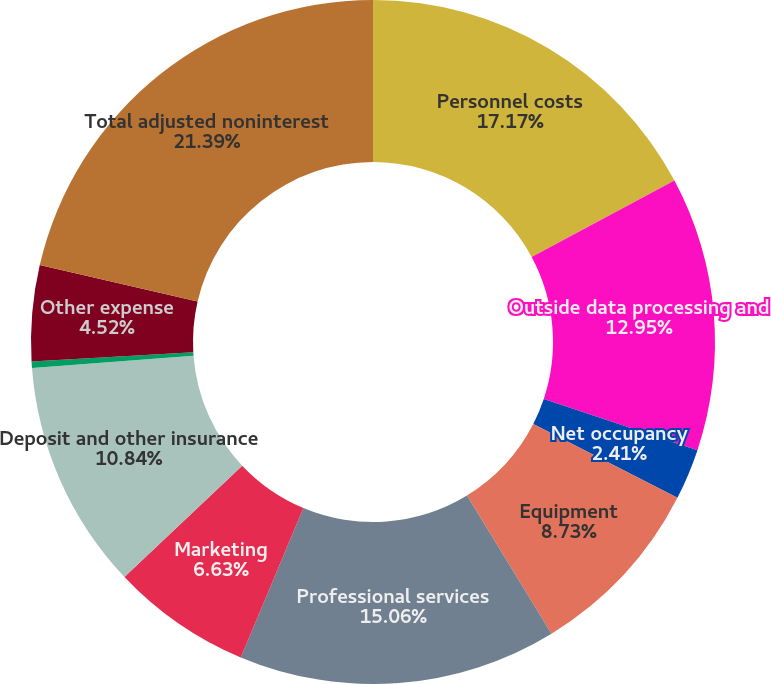Convert chart. <chart><loc_0><loc_0><loc_500><loc_500><pie_chart><fcel>Personnel costs<fcel>Outside data processing and<fcel>Net occupancy<fcel>Equipment<fcel>Professional services<fcel>Marketing<fcel>Deposit and other insurance<fcel>Amortization of intangibles<fcel>Other expense<fcel>Total adjusted noninterest<nl><fcel>17.17%<fcel>12.95%<fcel>2.41%<fcel>8.73%<fcel>15.06%<fcel>6.63%<fcel>10.84%<fcel>0.3%<fcel>4.52%<fcel>21.39%<nl></chart> 